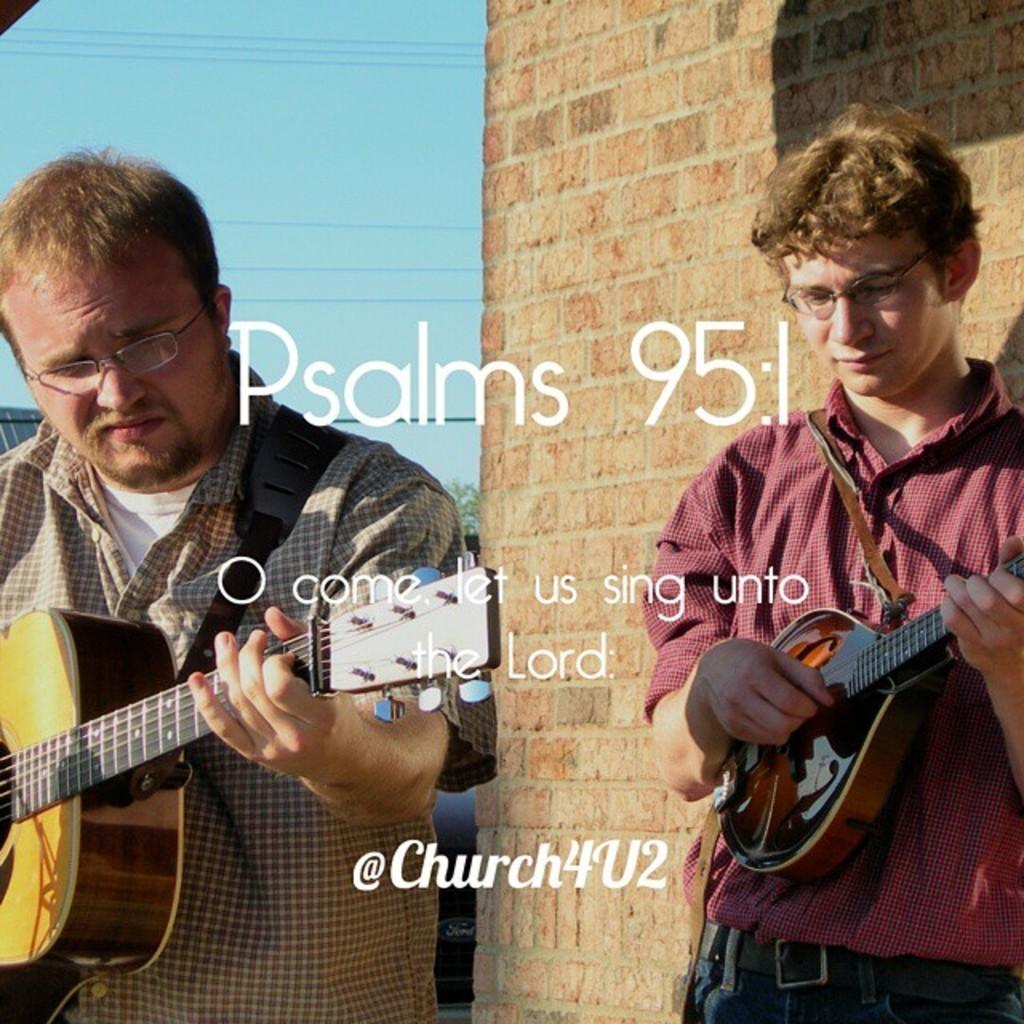How would you summarize this image in a sentence or two? In the picture we can find two men are standing and holding guitars in their hands. In the background we can see wall and the sky. 